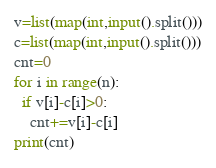Convert code to text. <code><loc_0><loc_0><loc_500><loc_500><_Python_>v=list(map(int,input().split()))
c=list(map(int,input().split()))
cnt=0
for i in range(n):
  if v[i]-c[i]>0:
    cnt+=v[i]-c[i]
print(cnt)</code> 